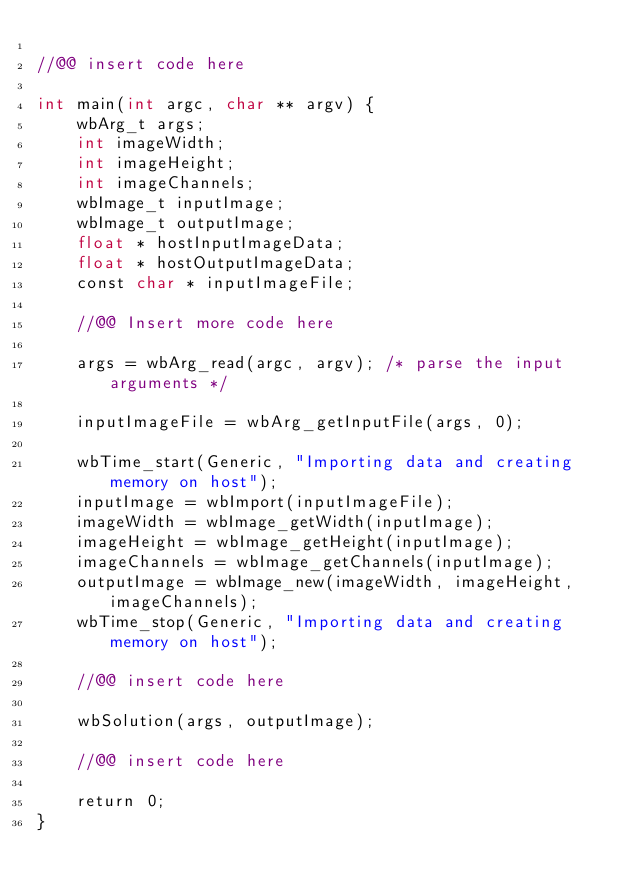Convert code to text. <code><loc_0><loc_0><loc_500><loc_500><_Cuda_>
//@@ insert code here

int main(int argc, char ** argv) {
    wbArg_t args;
    int imageWidth;
    int imageHeight;
    int imageChannels;
    wbImage_t inputImage;
    wbImage_t outputImage;
    float * hostInputImageData;
    float * hostOutputImageData;
    const char * inputImageFile;

    //@@ Insert more code here

    args = wbArg_read(argc, argv); /* parse the input arguments */

    inputImageFile = wbArg_getInputFile(args, 0);

    wbTime_start(Generic, "Importing data and creating memory on host");
    inputImage = wbImport(inputImageFile);
    imageWidth = wbImage_getWidth(inputImage);
    imageHeight = wbImage_getHeight(inputImage);
    imageChannels = wbImage_getChannels(inputImage);
    outputImage = wbImage_new(imageWidth, imageHeight, imageChannels);
    wbTime_stop(Generic, "Importing data and creating memory on host");

    //@@ insert code here

    wbSolution(args, outputImage);

    //@@ insert code here

    return 0;
}
</code> 